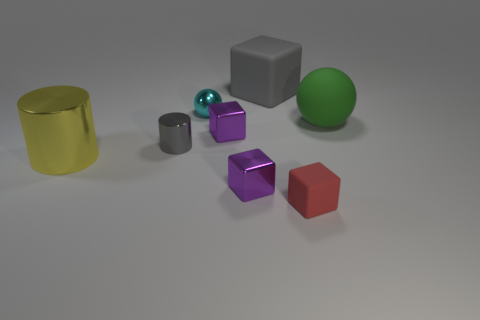Subtract all large gray rubber cubes. How many cubes are left? 3 Subtract all purple blocks. How many blocks are left? 2 Add 2 tiny purple balls. How many objects exist? 10 Subtract all balls. How many objects are left? 6 Subtract 1 blocks. How many blocks are left? 3 Add 6 blue matte cylinders. How many blue matte cylinders exist? 6 Subtract 1 yellow cylinders. How many objects are left? 7 Subtract all yellow cylinders. Subtract all cyan balls. How many cylinders are left? 1 Subtract all blue blocks. How many gray balls are left? 0 Subtract all tiny yellow metallic cylinders. Subtract all small red matte objects. How many objects are left? 7 